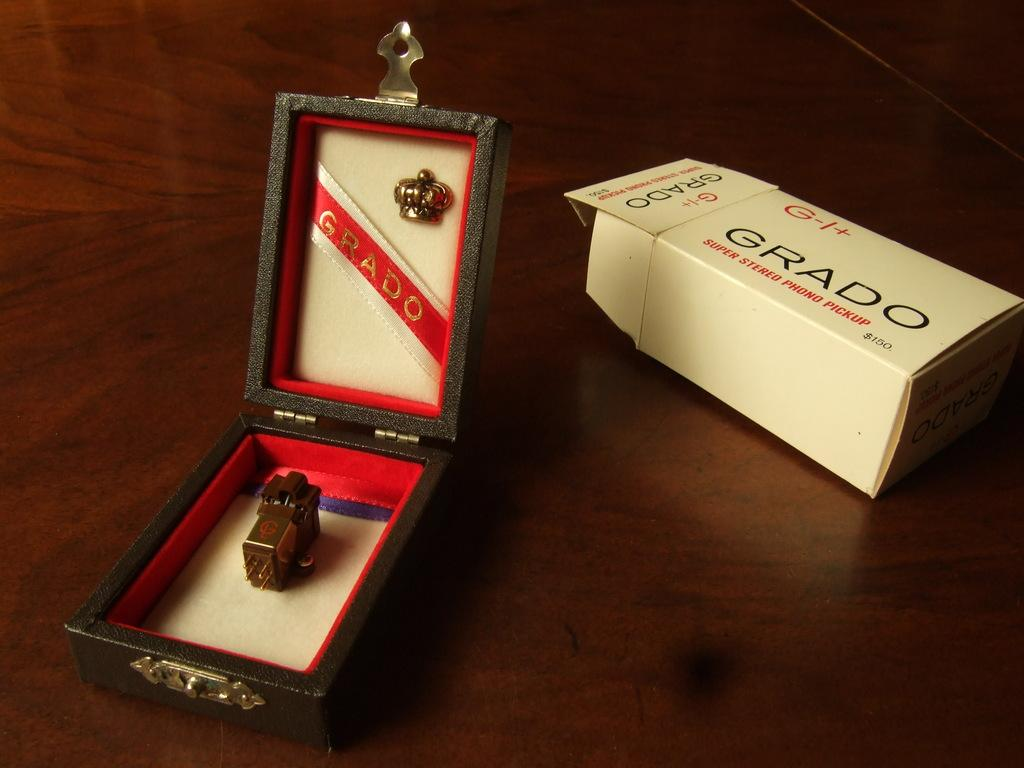Provide a one-sentence caption for the provided image. A white box from Grado is to the right of an open box with a metallic item in it. 